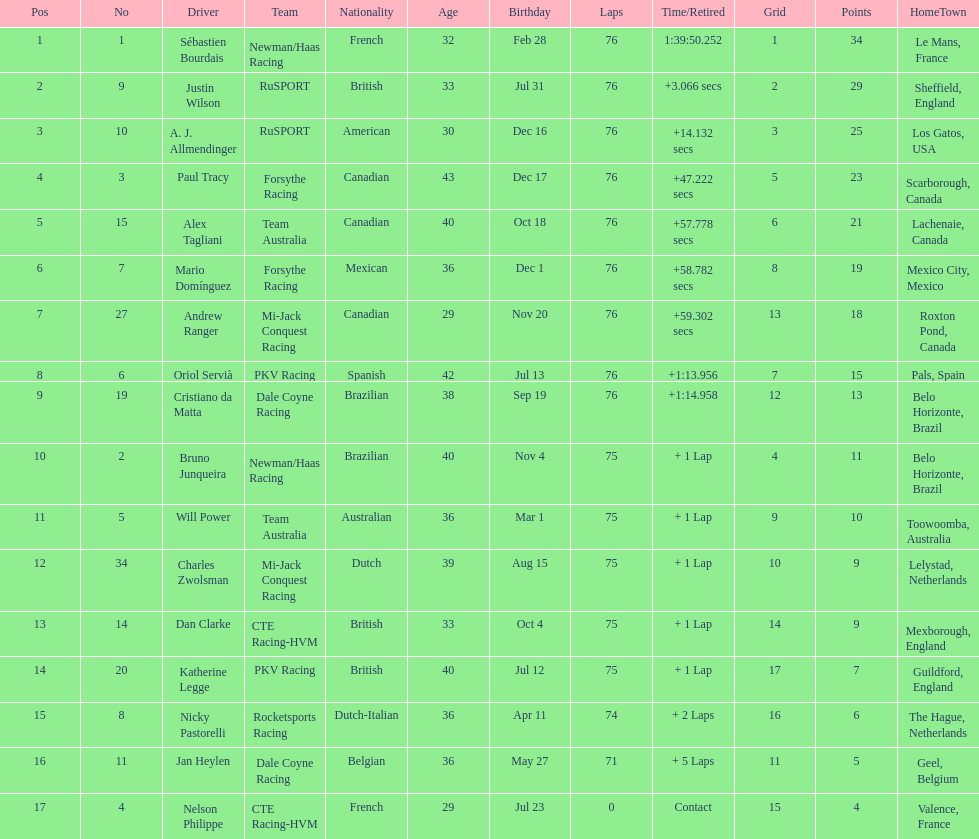What is the total point difference between the driver who received the most points and the driver who received the least? 30. 